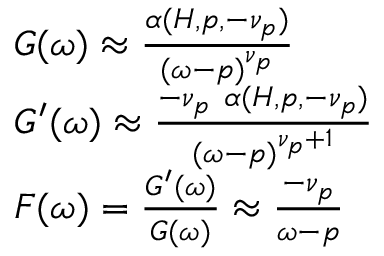Convert formula to latex. <formula><loc_0><loc_0><loc_500><loc_500>\begin{array} { r } { \begin{array} { r l } & { G ( \omega ) \approx \frac { \alpha ( H , p , - \nu _ { p } ) } { ( \omega - p ) ^ { \nu _ { p } } } } \\ & { G ^ { \prime } ( \omega ) \approx \frac { - \nu _ { p } \alpha ( H , p , - \nu _ { p } ) } { ( \omega - p ) ^ { \nu _ { p } + 1 } } } \\ & { F ( \omega ) = \frac { G ^ { \prime } ( \omega ) } { G ( \omega ) } \approx \frac { - \nu _ { p } } { \omega - p } } \end{array} } \end{array}</formula> 